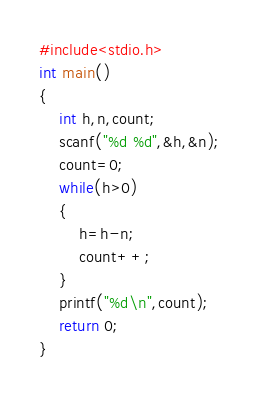Convert code to text. <code><loc_0><loc_0><loc_500><loc_500><_C_>#include<stdio.h>
int main()
{
    int h,n,count;
    scanf("%d %d",&h,&n);
    count=0;
    while(h>0)
    {
        h=h-n;
        count++;
    }
    printf("%d\n",count);
    return 0;
}
</code> 